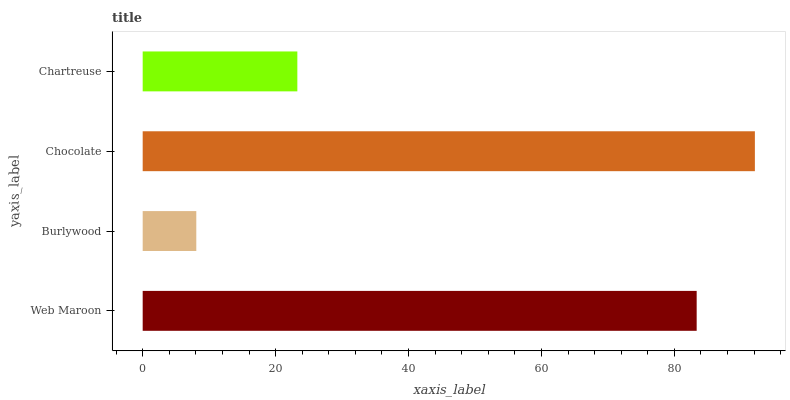Is Burlywood the minimum?
Answer yes or no. Yes. Is Chocolate the maximum?
Answer yes or no. Yes. Is Chocolate the minimum?
Answer yes or no. No. Is Burlywood the maximum?
Answer yes or no. No. Is Chocolate greater than Burlywood?
Answer yes or no. Yes. Is Burlywood less than Chocolate?
Answer yes or no. Yes. Is Burlywood greater than Chocolate?
Answer yes or no. No. Is Chocolate less than Burlywood?
Answer yes or no. No. Is Web Maroon the high median?
Answer yes or no. Yes. Is Chartreuse the low median?
Answer yes or no. Yes. Is Chocolate the high median?
Answer yes or no. No. Is Web Maroon the low median?
Answer yes or no. No. 